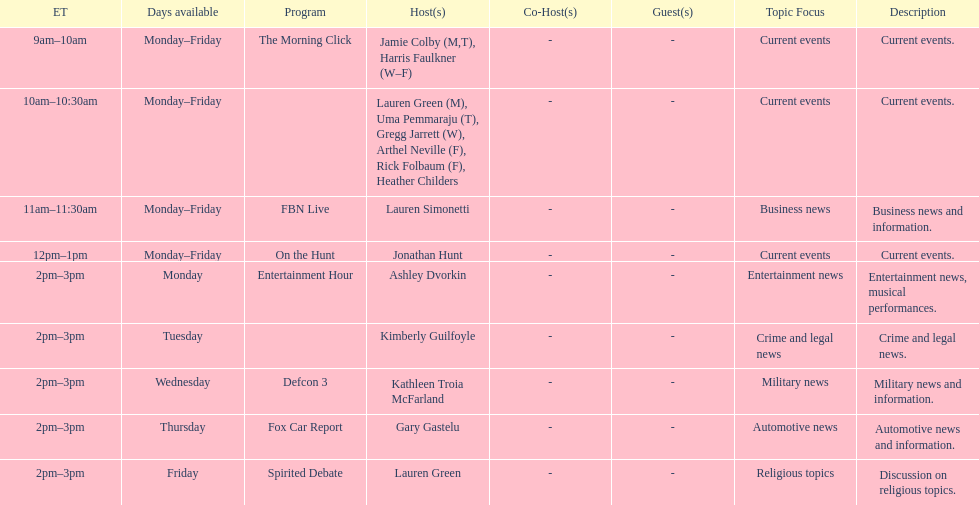How long does on the hunt run? 1 hour. 